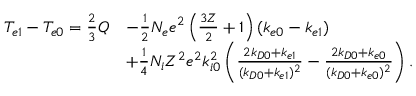Convert formula to latex. <formula><loc_0><loc_0><loc_500><loc_500>\begin{array} { r l } { T _ { e 1 } - T _ { e 0 } = \frac { 2 } { 3 } Q } & { - \frac { 1 } { 2 } N _ { e } e ^ { 2 } \left ( \frac { 3 Z } { 2 } + 1 \right ) ( k _ { e 0 } - k _ { e 1 } ) } \\ & { + \frac { 1 } { 4 } N _ { i } Z ^ { 2 } e ^ { 2 } k _ { i 0 } ^ { 2 } \left ( \frac { 2 k _ { D 0 } + k _ { e 1 } } { ( k _ { D 0 } + k _ { e 1 } ) ^ { 2 } } - \frac { 2 k _ { D 0 } + k _ { e 0 } } { ( k _ { D 0 } + k _ { e 0 } ) ^ { 2 } } \right ) . } \end{array}</formula> 